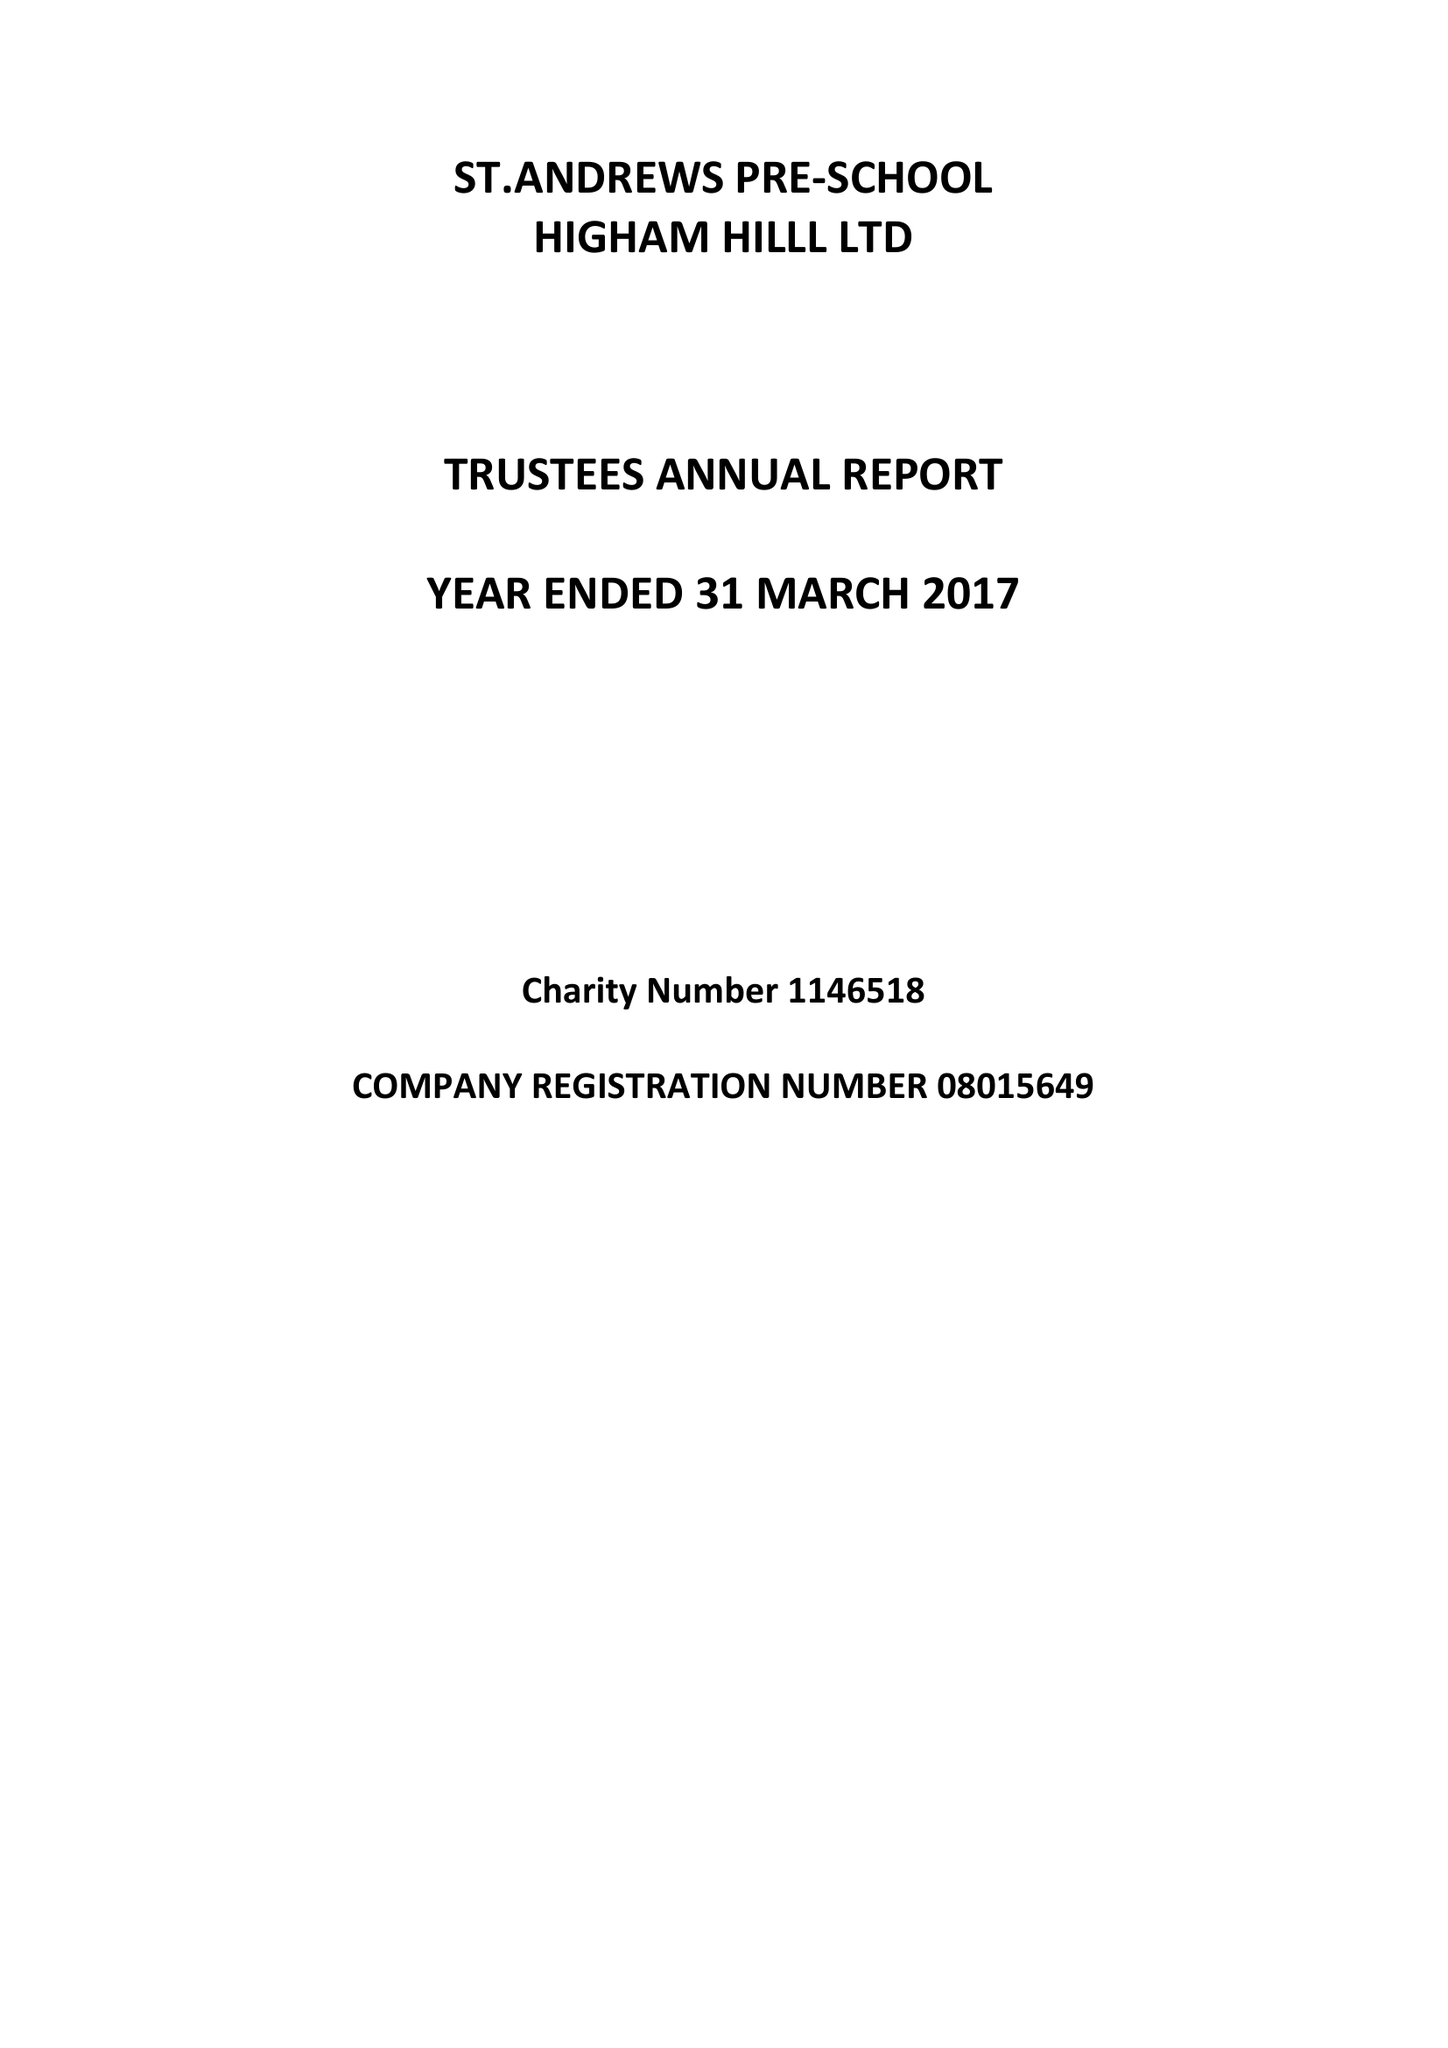What is the value for the address__street_line?
Answer the question using a single word or phrase. CHURCH ROAD 